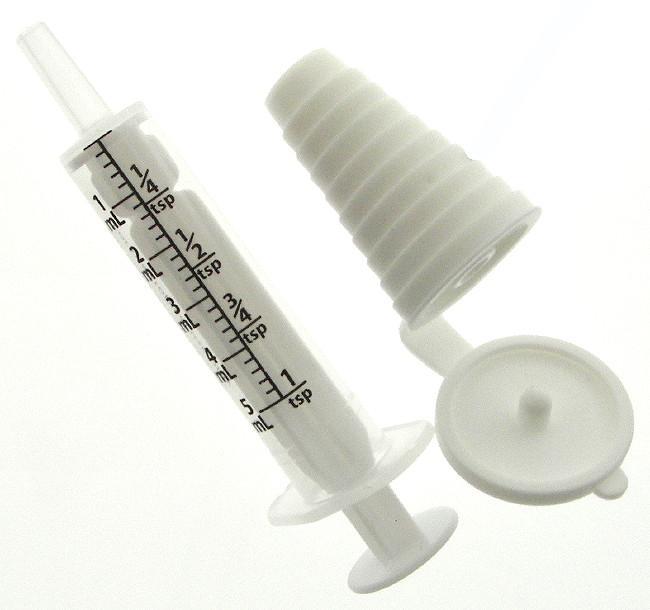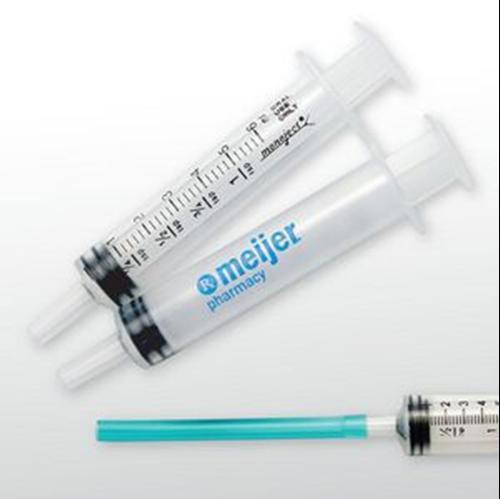The first image is the image on the left, the second image is the image on the right. Analyze the images presented: Is the assertion "At least one image includes an item resembling a pacifier next to a syringe." valid? Answer yes or no. No. The first image is the image on the left, the second image is the image on the right. For the images displayed, is the sentence "The left image has a syringe with a nozzle, the right image has at least three syringes, and no image has a pacifier." factually correct? Answer yes or no. Yes. 